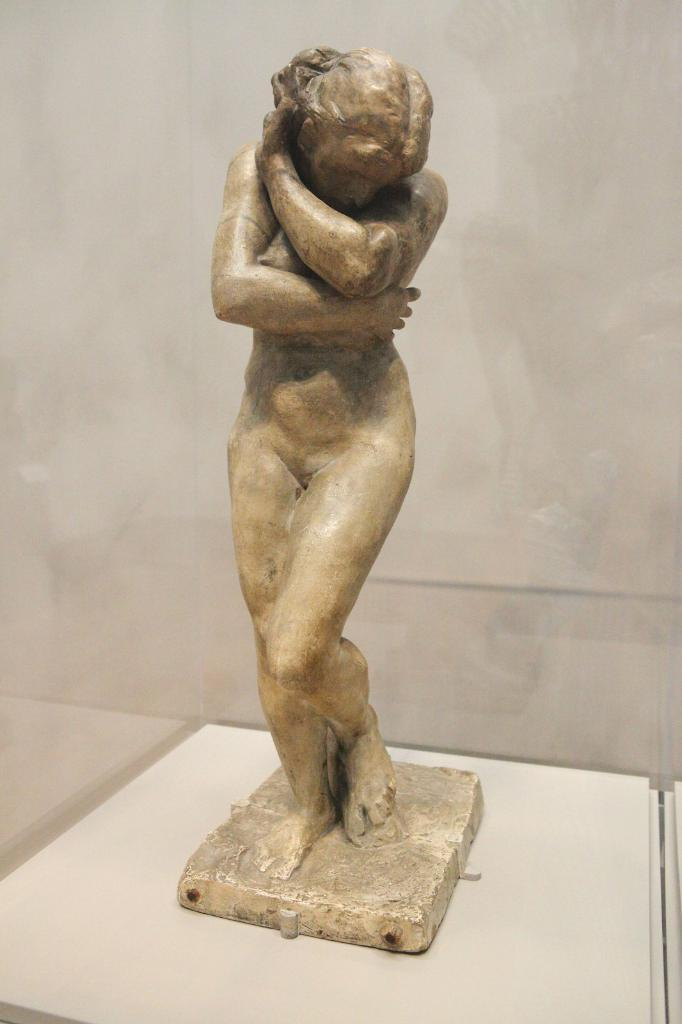What is the main subject in the image? There is a statue in the image. Can you describe the setting of the image? There is a wall in the background of the image. What type of songs can be heard coming from the statue in the image? There is no indication in the image that the statue is producing any sounds, so it's not possible to determine what, if any, songs might be heard. 